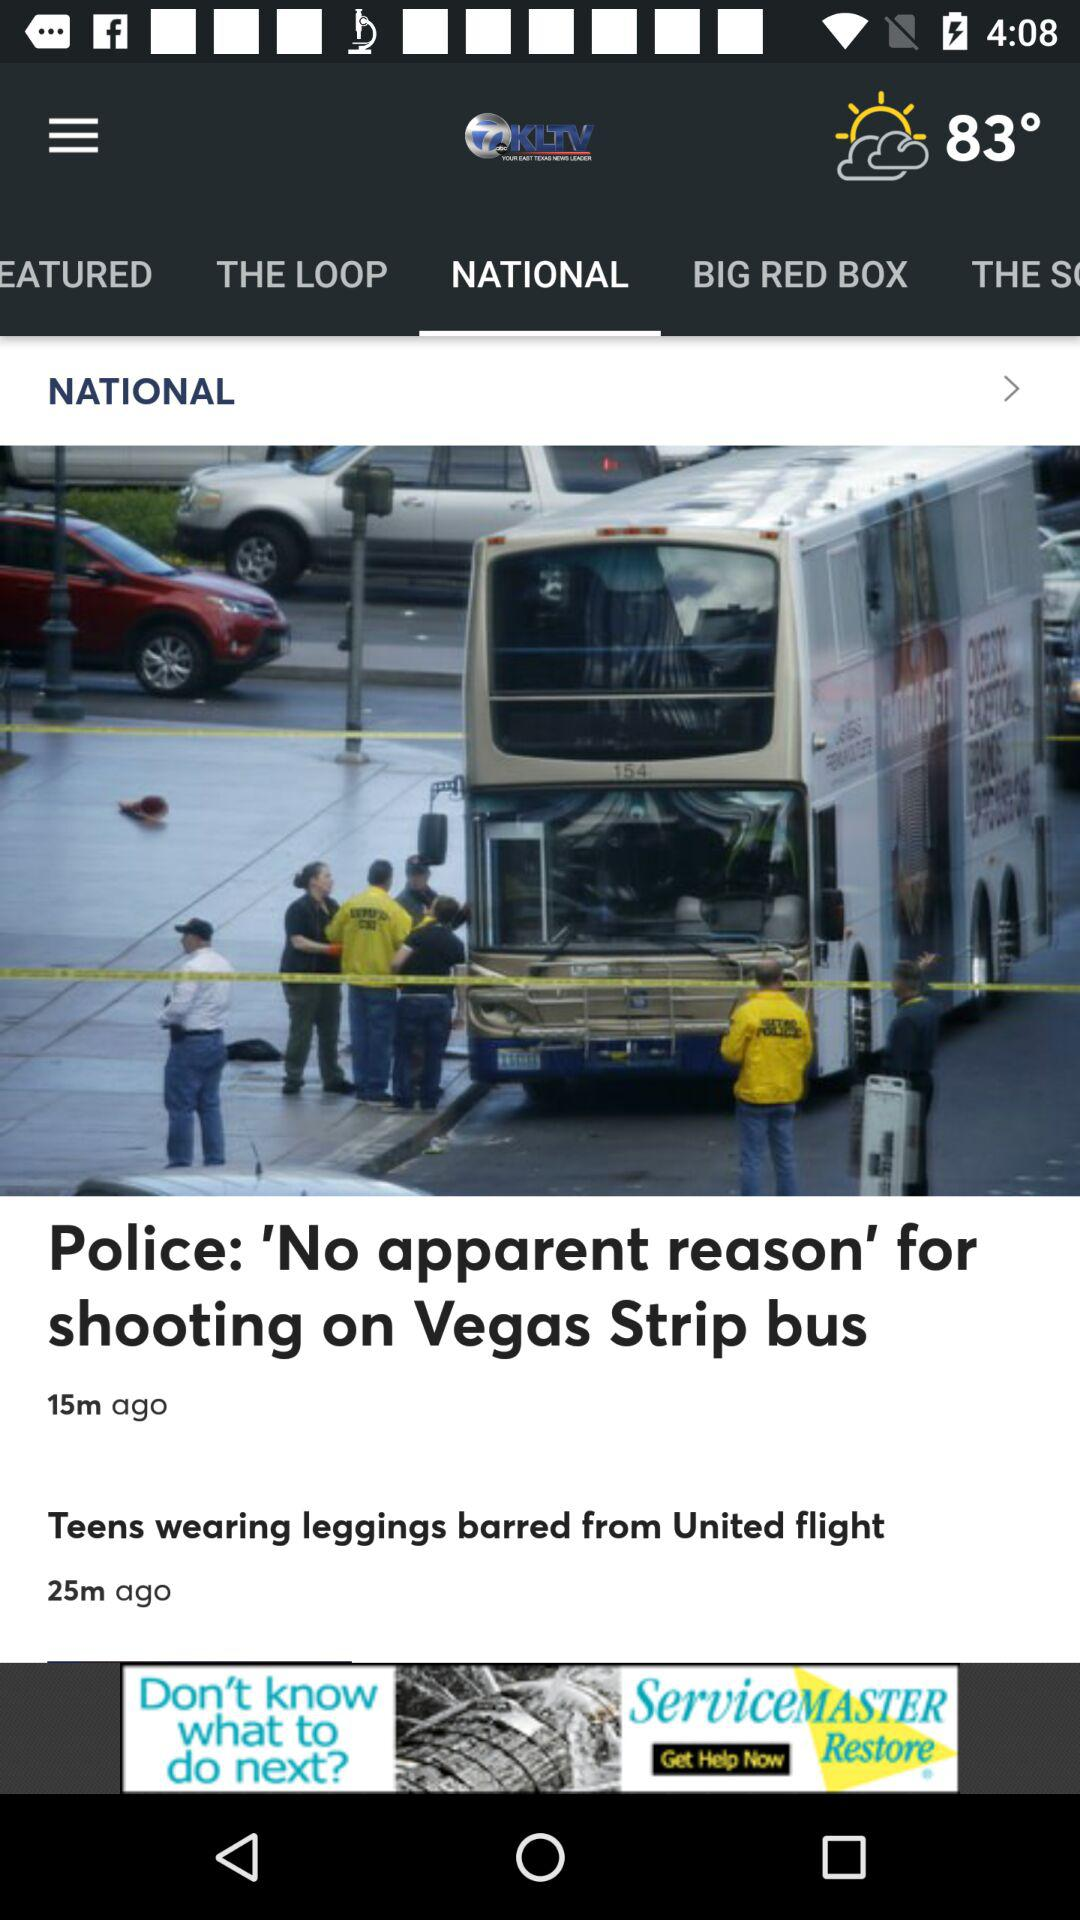Which tab am I on? You are on the "NATIONAL" tab. 